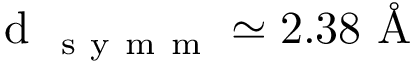<formula> <loc_0><loc_0><loc_500><loc_500>d _ { s y m m } \simeq 2 . 3 8 \AA</formula> 